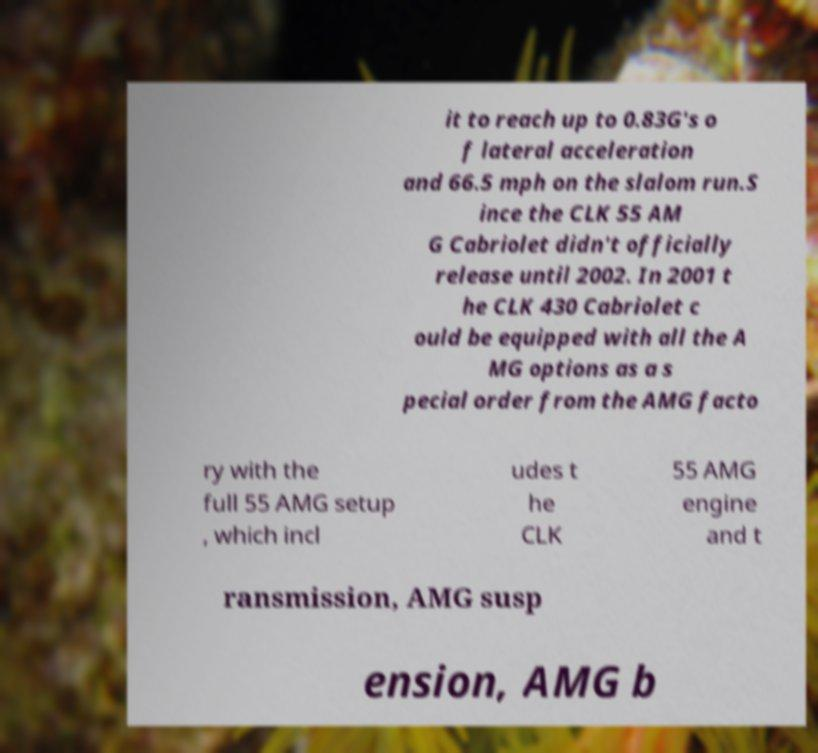Please read and relay the text visible in this image. What does it say? it to reach up to 0.83G's o f lateral acceleration and 66.5 mph on the slalom run.S ince the CLK 55 AM G Cabriolet didn't officially release until 2002. In 2001 t he CLK 430 Cabriolet c ould be equipped with all the A MG options as a s pecial order from the AMG facto ry with the full 55 AMG setup , which incl udes t he CLK 55 AMG engine and t ransmission, AMG susp ension, AMG b 